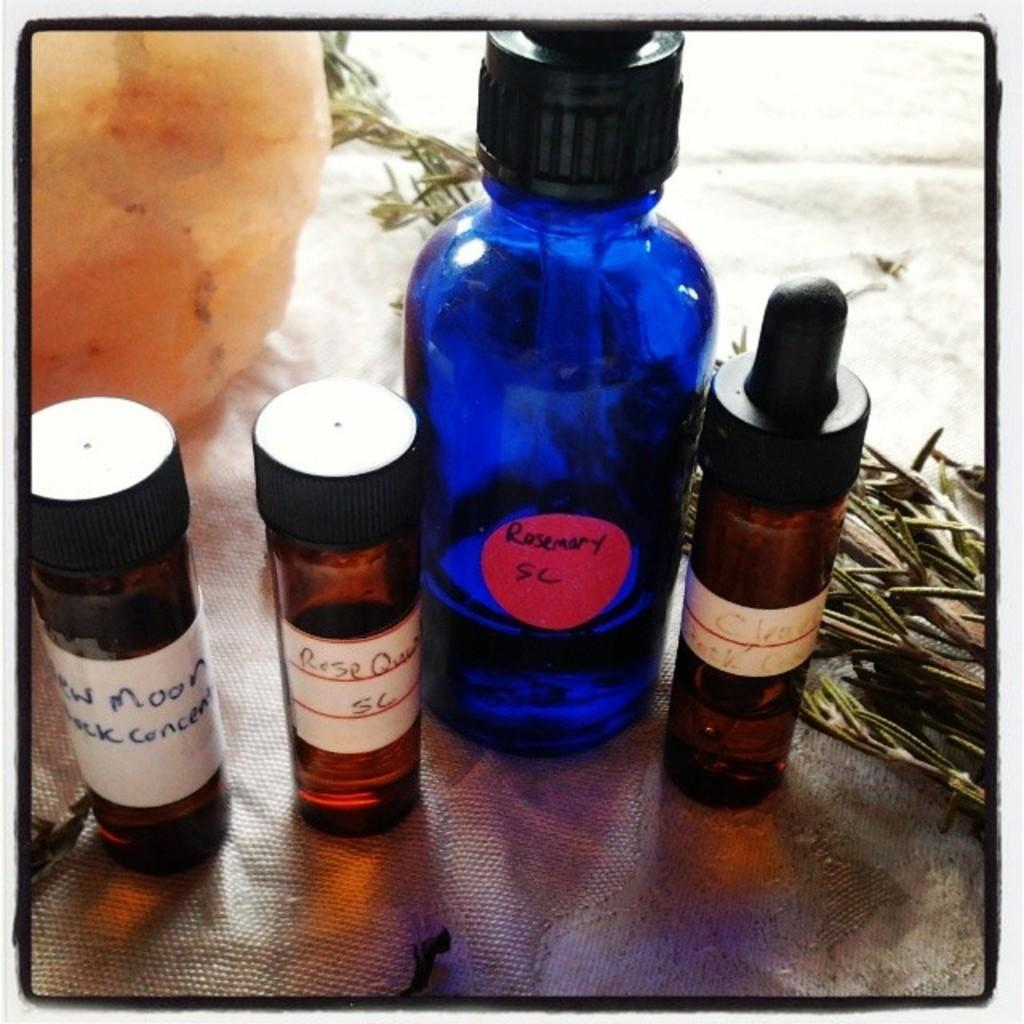<image>
Create a compact narrative representing the image presented. Blue bottle saying Rosemary in between some other bottles. 